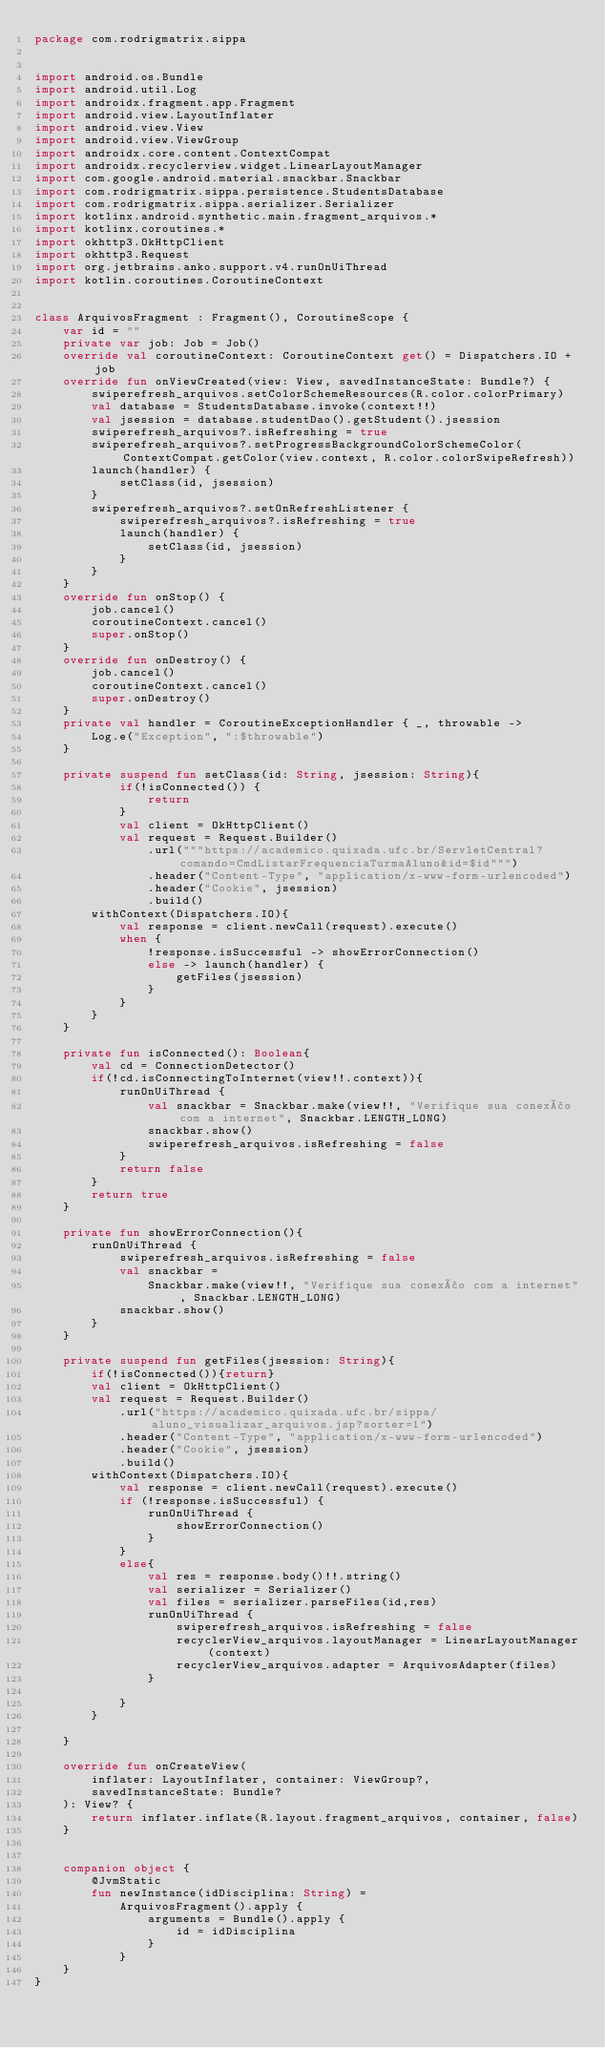Convert code to text. <code><loc_0><loc_0><loc_500><loc_500><_Kotlin_>package com.rodrigmatrix.sippa


import android.os.Bundle
import android.util.Log
import androidx.fragment.app.Fragment
import android.view.LayoutInflater
import android.view.View
import android.view.ViewGroup
import androidx.core.content.ContextCompat
import androidx.recyclerview.widget.LinearLayoutManager
import com.google.android.material.snackbar.Snackbar
import com.rodrigmatrix.sippa.persistence.StudentsDatabase
import com.rodrigmatrix.sippa.serializer.Serializer
import kotlinx.android.synthetic.main.fragment_arquivos.*
import kotlinx.coroutines.*
import okhttp3.OkHttpClient
import okhttp3.Request
import org.jetbrains.anko.support.v4.runOnUiThread
import kotlin.coroutines.CoroutineContext


class ArquivosFragment : Fragment(), CoroutineScope {
    var id = ""
    private var job: Job = Job()
    override val coroutineContext: CoroutineContext get() = Dispatchers.IO + job
    override fun onViewCreated(view: View, savedInstanceState: Bundle?) {
        swiperefresh_arquivos.setColorSchemeResources(R.color.colorPrimary)
        val database = StudentsDatabase.invoke(context!!)
        val jsession = database.studentDao().getStudent().jsession
        swiperefresh_arquivos?.isRefreshing = true
        swiperefresh_arquivos?.setProgressBackgroundColorSchemeColor(ContextCompat.getColor(view.context, R.color.colorSwipeRefresh))
        launch(handler) {
            setClass(id, jsession)
        }
        swiperefresh_arquivos?.setOnRefreshListener {
            swiperefresh_arquivos?.isRefreshing = true
            launch(handler) {
                setClass(id, jsession)
            }
        }
    }
    override fun onStop() {
        job.cancel()
        coroutineContext.cancel()
        super.onStop()
    }
    override fun onDestroy() {
        job.cancel()
        coroutineContext.cancel()
        super.onDestroy()
    }
    private val handler = CoroutineExceptionHandler { _, throwable ->
        Log.e("Exception", ":$throwable")
    }

    private suspend fun setClass(id: String, jsession: String){
            if(!isConnected()) {
                return
            }
            val client = OkHttpClient()
            val request = Request.Builder()
                .url("""https://academico.quixada.ufc.br/ServletCentral?comando=CmdListarFrequenciaTurmaAluno&id=$id""")
                .header("Content-Type", "application/x-www-form-urlencoded")
                .header("Cookie", jsession)
                .build()
        withContext(Dispatchers.IO){
            val response = client.newCall(request).execute()
            when {
                !response.isSuccessful -> showErrorConnection()
                else -> launch(handler) {
                    getFiles(jsession)
                }
            }
        }
    }

    private fun isConnected(): Boolean{
        val cd = ConnectionDetector()
        if(!cd.isConnectingToInternet(view!!.context)){
            runOnUiThread {
                val snackbar = Snackbar.make(view!!, "Verifique sua conexão com a internet", Snackbar.LENGTH_LONG)
                snackbar.show()
                swiperefresh_arquivos.isRefreshing = false
            }
            return false
        }
        return true
    }

    private fun showErrorConnection(){
        runOnUiThread {
            swiperefresh_arquivos.isRefreshing = false
            val snackbar =
                Snackbar.make(view!!, "Verifique sua conexão com a internet", Snackbar.LENGTH_LONG)
            snackbar.show()
        }
    }

    private suspend fun getFiles(jsession: String){
        if(!isConnected()){return}
        val client = OkHttpClient()
        val request = Request.Builder()
            .url("https://academico.quixada.ufc.br/sippa/aluno_visualizar_arquivos.jsp?sorter=1")
            .header("Content-Type", "application/x-www-form-urlencoded")
            .header("Cookie", jsession)
            .build()
        withContext(Dispatchers.IO){
            val response = client.newCall(request).execute()
            if (!response.isSuccessful) {
                runOnUiThread {
                    showErrorConnection()
                }
            }
            else{
                val res = response.body()!!.string()
                val serializer = Serializer()
                val files = serializer.parseFiles(id,res)
                runOnUiThread {
                    swiperefresh_arquivos.isRefreshing = false
                    recyclerView_arquivos.layoutManager = LinearLayoutManager(context)
                    recyclerView_arquivos.adapter = ArquivosAdapter(files)
                }

            }
        }

    }

    override fun onCreateView(
        inflater: LayoutInflater, container: ViewGroup?,
        savedInstanceState: Bundle?
    ): View? {
        return inflater.inflate(R.layout.fragment_arquivos, container, false)
    }


    companion object {
        @JvmStatic
        fun newInstance(idDisciplina: String) =
            ArquivosFragment().apply {
                arguments = Bundle().apply {
                    id = idDisciplina
                }
            }
    }
}
</code> 